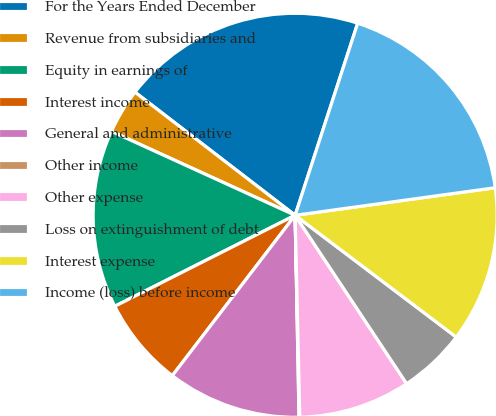Convert chart to OTSL. <chart><loc_0><loc_0><loc_500><loc_500><pie_chart><fcel>For the Years Ended December<fcel>Revenue from subsidiaries and<fcel>Equity in earnings of<fcel>Interest income<fcel>General and administrative<fcel>Other income<fcel>Other expense<fcel>Loss on extinguishment of debt<fcel>Interest expense<fcel>Income (loss) before income<nl><fcel>19.58%<fcel>3.61%<fcel>14.26%<fcel>7.16%<fcel>10.71%<fcel>0.06%<fcel>8.94%<fcel>5.39%<fcel>12.48%<fcel>17.81%<nl></chart> 